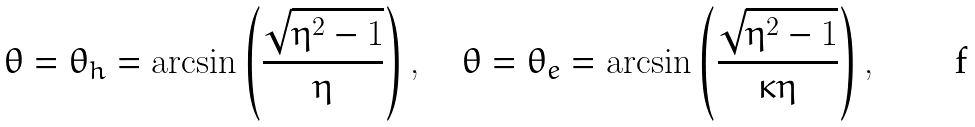Convert formula to latex. <formula><loc_0><loc_0><loc_500><loc_500>\theta = \theta _ { h } = \arcsin \left ( \frac { \sqrt { \eta ^ { 2 } - 1 } } { \eta } \right ) , \quad \theta = \theta _ { e } = \arcsin \left ( \frac { \sqrt { \eta ^ { 2 } - 1 } } { \kappa \eta } \right ) ,</formula> 